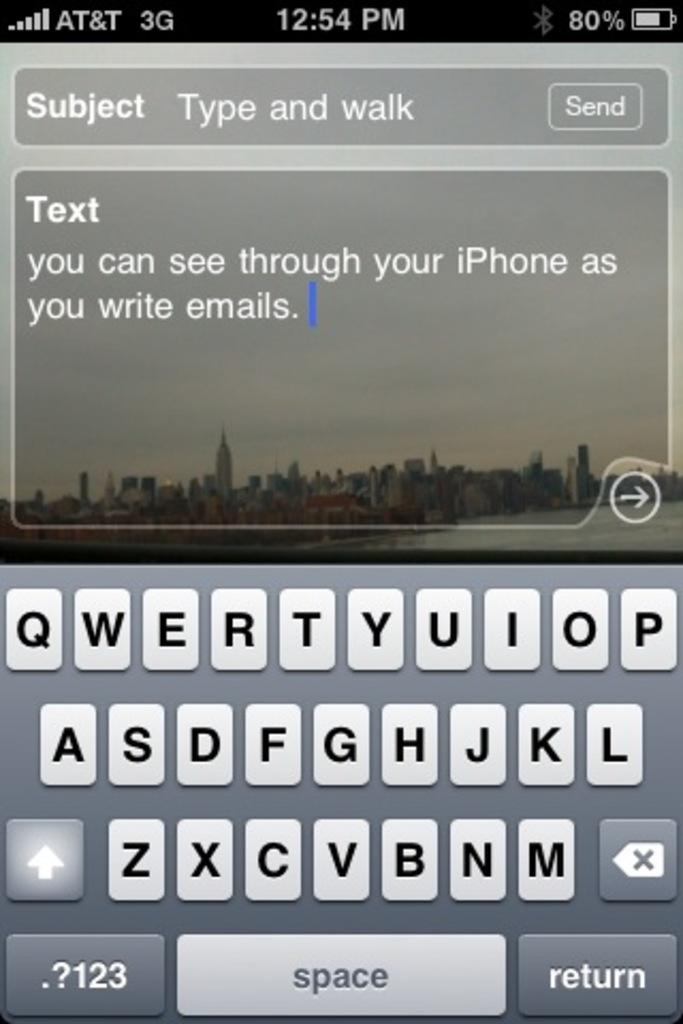<image>
Offer a succinct explanation of the picture presented. A phone screen of a text that says you can see through your iPhone. 